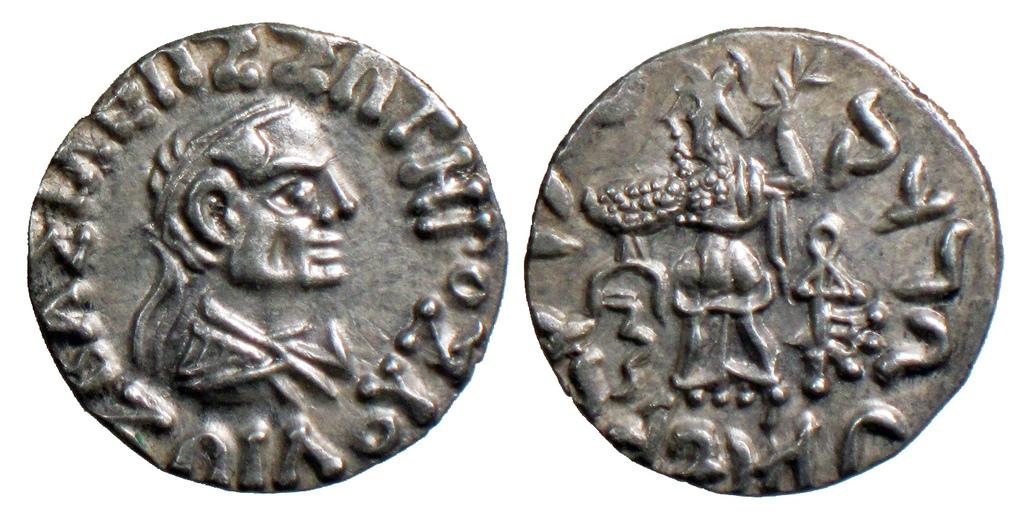What objects are present in the image? There are coins in the image. What features can be seen on the coins? The coins have letters and pictures on them. What type of story is being told by the coins in the image? There is no story being told by the coins in the image. 